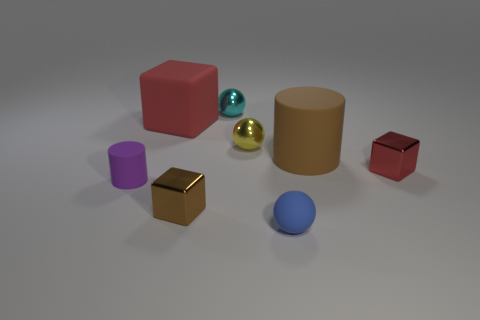There is a small shiny cube that is to the right of the brown shiny block; does it have the same color as the large matte block?
Provide a succinct answer. Yes. The metal thing that is the same color as the rubber cube is what size?
Your answer should be compact. Small. Is there a metallic block of the same color as the big matte cube?
Ensure brevity in your answer.  Yes. There is a metal object that is the same color as the large cube; what shape is it?
Your answer should be compact. Cube. There is a small blue ball on the right side of the purple thing; are there any small balls that are on the left side of it?
Your answer should be very brief. Yes. There is a big thing that is on the right side of the small cyan metallic sphere; is it the same color as the tiny block left of the matte ball?
Offer a very short reply. Yes. The tiny rubber sphere is what color?
Offer a very short reply. Blue. Are there any other things of the same color as the big rubber cube?
Provide a succinct answer. Yes. There is a cube that is on the left side of the large cylinder and in front of the yellow sphere; what color is it?
Offer a very short reply. Brown. Does the cylinder that is to the left of the brown rubber cylinder have the same size as the large brown matte cylinder?
Your response must be concise. No. 